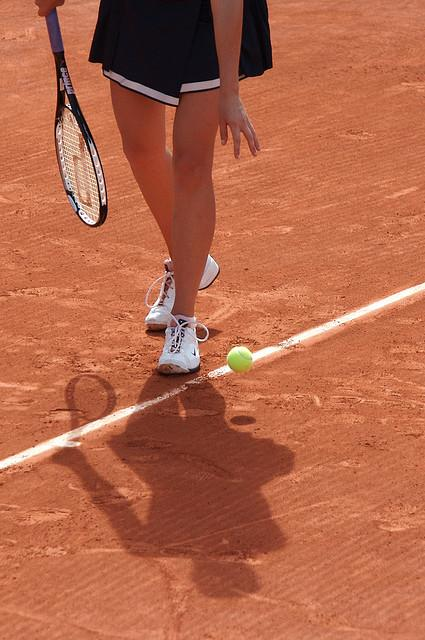What color are the logos on the shoes which this tennis playing woman is wearing? black 